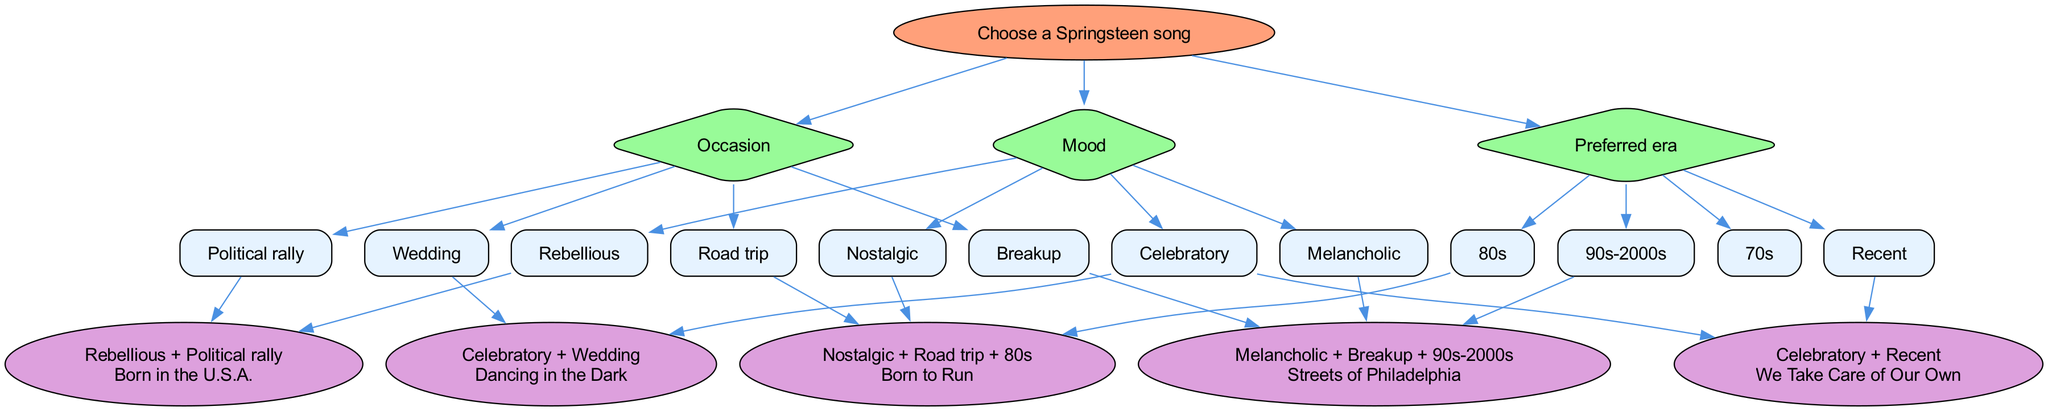What is the root node of the diagram? The root node is labeled "Choose a Springsteen song". It is the starting point of the decision tree from which all branches emerge.
Answer: Choose a Springsteen song How many branches are present in the diagram? There are three branches in the diagram: Mood, Occasion, and Preferred era. These branches categorize the choices available for selecting a song.
Answer: 3 Which song corresponds to the condition "Celebratory + Wedding"? The song that corresponds to this condition is "Dancing in the Dark". It is the result of following the flow based on the specified emotions and occasions.
Answer: Dancing in the Dark If someone feels melancholic and is going through a breakup, which song should they choose? The correct song for someone feeling melancholic during a breakup is "Streets of Philadelphia". This song is reached by following the decision tree through the designated emotions and circumstances.
Answer: Streets of Philadelphia What conditions lead to the song "Born to Run"? The conditions that lead to "Born to Run" are "Nostalgic + Road trip + 80s". The reasoning takes into account both the mood and the era preferences along with the context of a road trip.
Answer: Nostalgic + Road trip + 80s Which mood is associated with the song "Born in the U.S.A."? The mood associated with "Born in the U.S.A." is "Rebellious". This is identified by following the branch that specifies the nature of the occasion as a political rally.
Answer: Rebellious What is the preferred era associated with the song "We Take Care of Our Own"? The preferred era associated with "We Take Care of Our Own" is "Recent". This connection is made by selecting the celebratory mood combined with the most current era of Springsteen's music.
Answer: Recent How do you reach the song "We Take Care of Our Own"? To reach "We Take Care of Our Own", you start from the root, choose the "Celebratory" mood, and then select the "Recent" preference. This shows the flow through the branches leading to the final song choice.
Answer: Celebratory + Recent What song would be selected at a political rally for a rebellious mood? The selected song for a rebellious mood at a political rally is "Born in the U.S.A." This outcome follows from the appropriate conditions set in the decision-making process.
Answer: Born in the U.S.A 